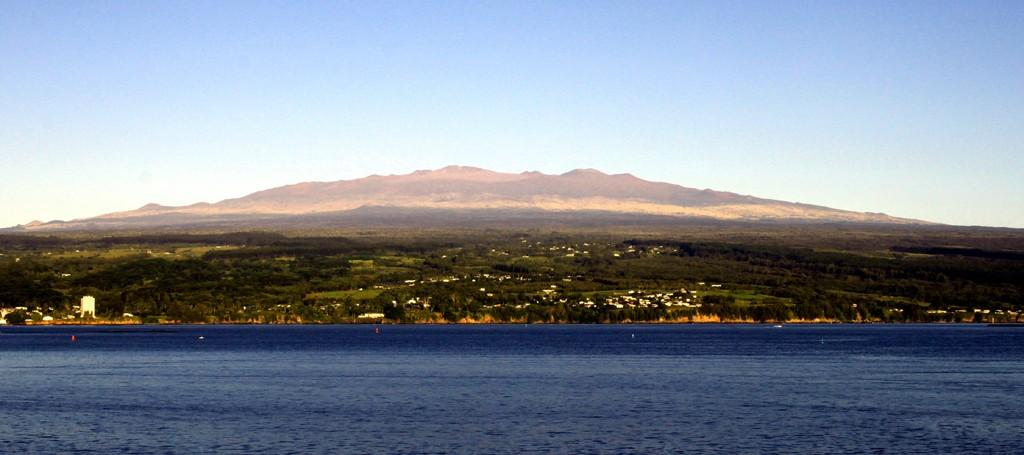What is present at the bottom of the image? There is water at the bottom of the image. What can be seen in the background of the image? There are trees, mountains, and buildings in the background of the image. What is visible at the top of the image? The sky is visible at the top of the image. What type of desk can be seen in the image? There is no desk present in the image. How is the scale used in the image? There is no scale present in the image, so it cannot be used. 